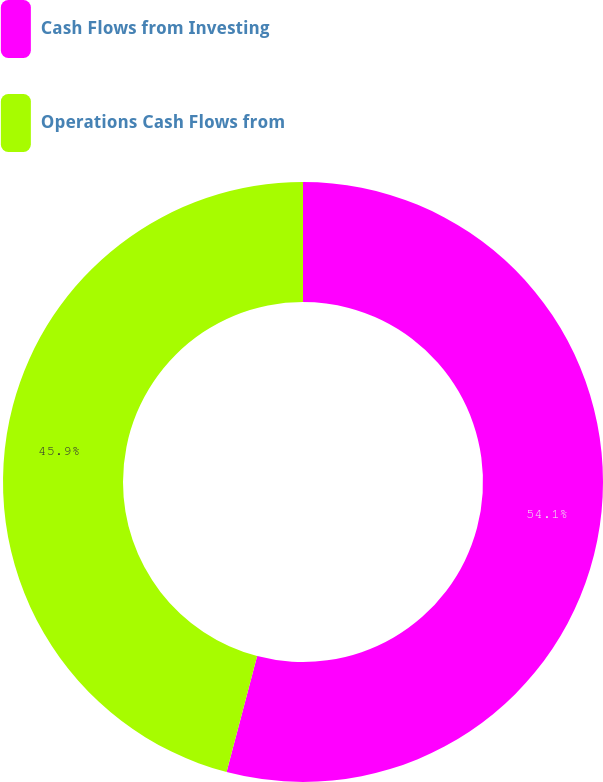Convert chart. <chart><loc_0><loc_0><loc_500><loc_500><pie_chart><fcel>Cash Flows from Investing<fcel>Operations Cash Flows from<nl><fcel>54.1%<fcel>45.9%<nl></chart> 